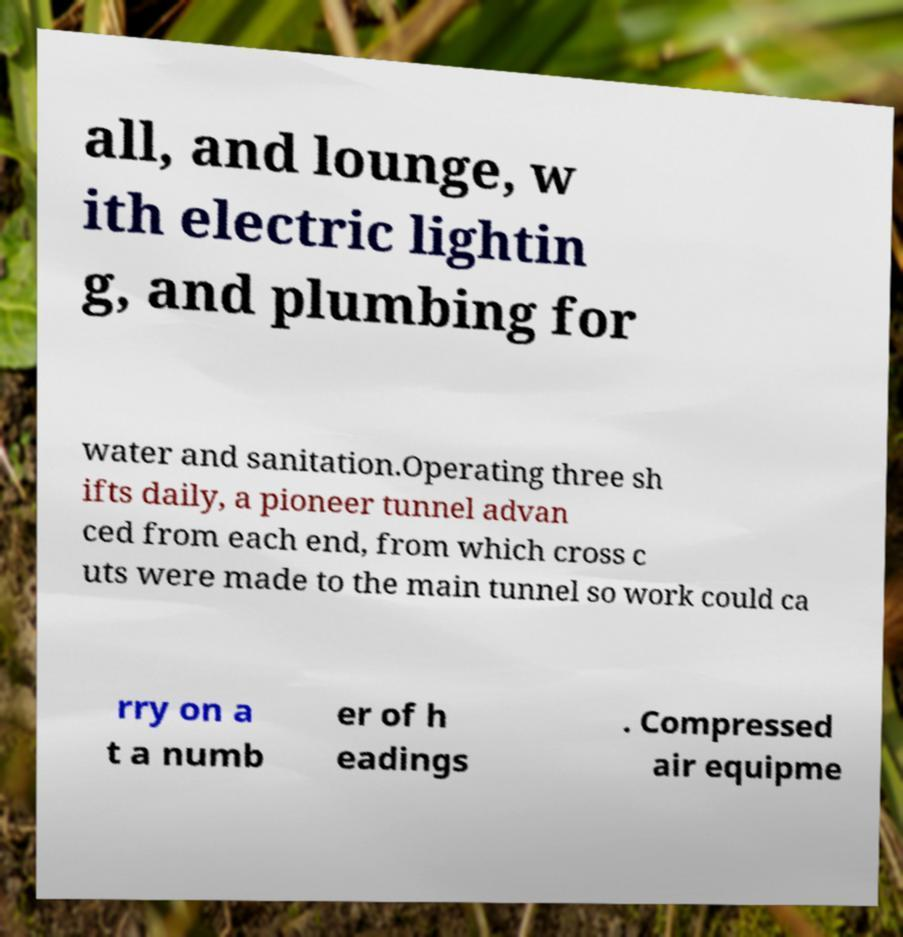Could you extract and type out the text from this image? all, and lounge, w ith electric lightin g, and plumbing for water and sanitation.Operating three sh ifts daily, a pioneer tunnel advan ced from each end, from which cross c uts were made to the main tunnel so work could ca rry on a t a numb er of h eadings . Compressed air equipme 